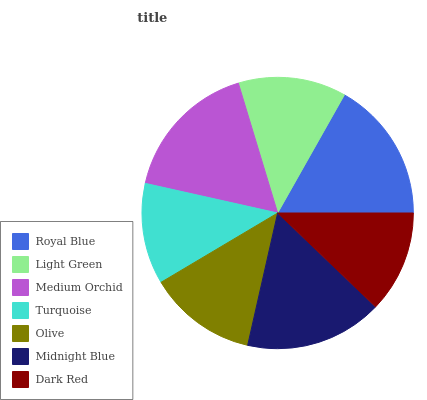Is Turquoise the minimum?
Answer yes or no. Yes. Is Medium Orchid the maximum?
Answer yes or no. Yes. Is Light Green the minimum?
Answer yes or no. No. Is Light Green the maximum?
Answer yes or no. No. Is Royal Blue greater than Light Green?
Answer yes or no. Yes. Is Light Green less than Royal Blue?
Answer yes or no. Yes. Is Light Green greater than Royal Blue?
Answer yes or no. No. Is Royal Blue less than Light Green?
Answer yes or no. No. Is Olive the high median?
Answer yes or no. Yes. Is Olive the low median?
Answer yes or no. Yes. Is Medium Orchid the high median?
Answer yes or no. No. Is Medium Orchid the low median?
Answer yes or no. No. 